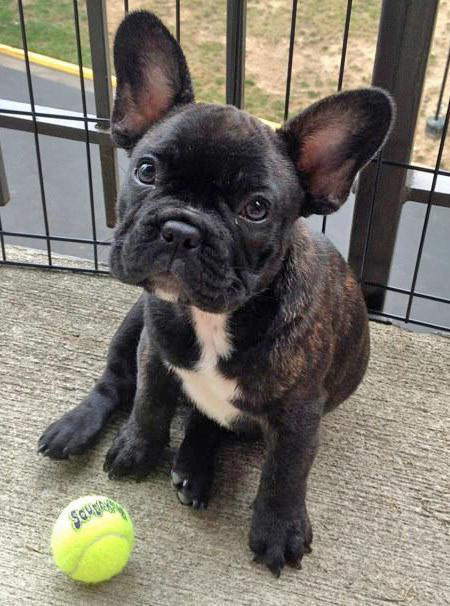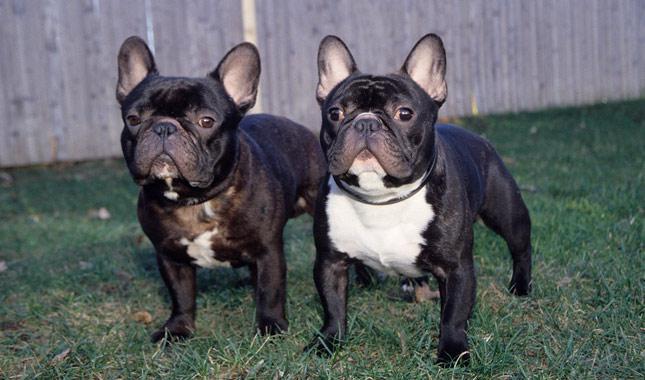The first image is the image on the left, the second image is the image on the right. For the images displayed, is the sentence "All of the dogs are dark colored, and the right image contains twice the dogs as the left image." factually correct? Answer yes or no. Yes. The first image is the image on the left, the second image is the image on the right. Analyze the images presented: Is the assertion "There are two dogs in the grass." valid? Answer yes or no. Yes. 